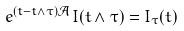Convert formula to latex. <formula><loc_0><loc_0><loc_500><loc_500>e ^ { ( t - t \wedge \tau ) \mathcal { A } } I ( t \wedge \tau ) = I _ { \tau } ( t )</formula> 